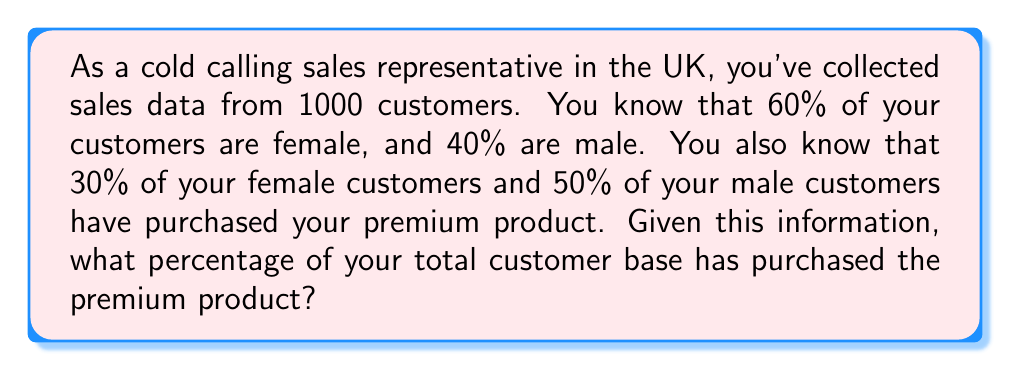Could you help me with this problem? Let's approach this step-by-step:

1. Define variables:
   Let $F$ be the number of female customers
   Let $M$ be the number of male customers
   Let $T$ be the total number of customers

2. Calculate the number of female and male customers:
   $F = 60\% \times T = 0.6 \times 1000 = 600$
   $M = 40\% \times T = 0.4 \times 1000 = 400$

3. Calculate the number of female customers who purchased the premium product:
   $F_{premium} = 30\% \times F = 0.3 \times 600 = 180$

4. Calculate the number of male customers who purchased the premium product:
   $M_{premium} = 50\% \times M = 0.5 \times 400 = 200$

5. Calculate the total number of customers who purchased the premium product:
   $T_{premium} = F_{premium} + M_{premium} = 180 + 200 = 380$

6. Calculate the percentage of total customers who purchased the premium product:
   $$\text{Percentage} = \frac{T_{premium}}{T} \times 100\% = \frac{380}{1000} \times 100\% = 38\%$$

Therefore, 38% of the total customer base has purchased the premium product.
Answer: 38% 